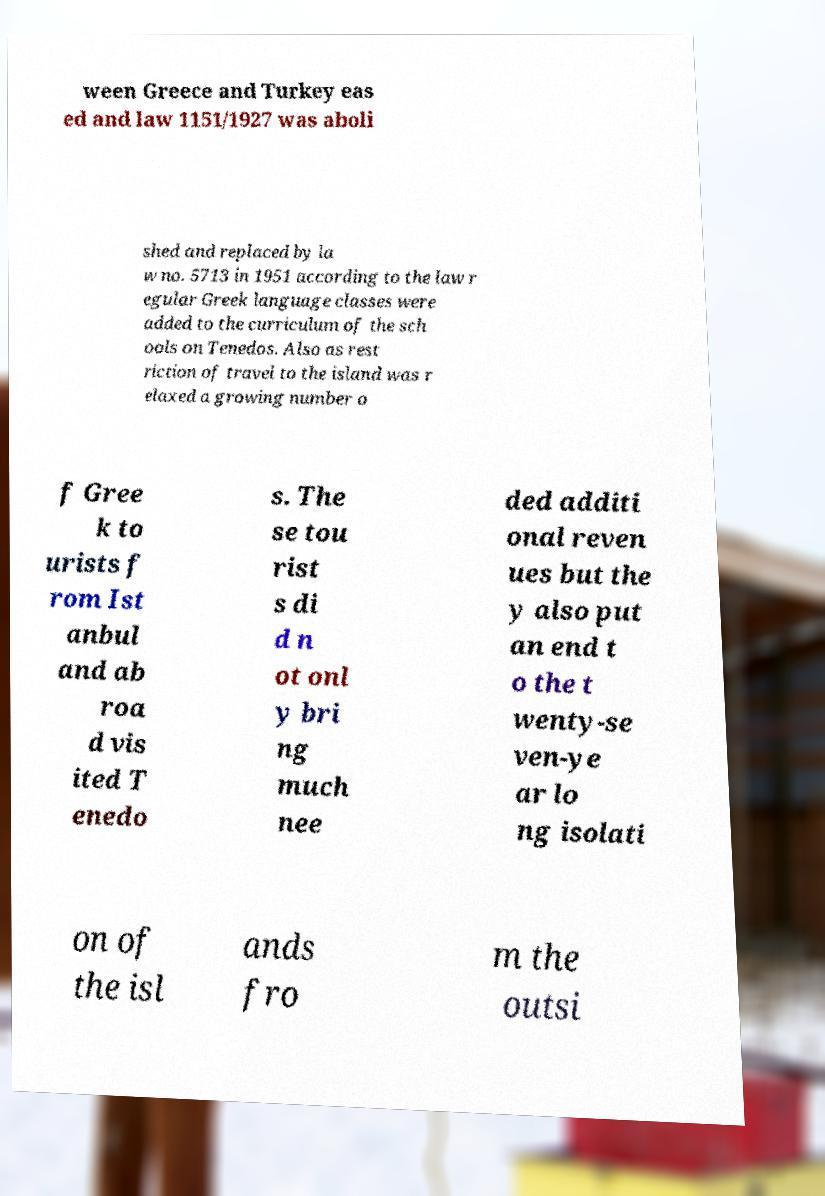Could you assist in decoding the text presented in this image and type it out clearly? ween Greece and Turkey eas ed and law 1151/1927 was aboli shed and replaced by la w no. 5713 in 1951 according to the law r egular Greek language classes were added to the curriculum of the sch ools on Tenedos. Also as rest riction of travel to the island was r elaxed a growing number o f Gree k to urists f rom Ist anbul and ab roa d vis ited T enedo s. The se tou rist s di d n ot onl y bri ng much nee ded additi onal reven ues but the y also put an end t o the t wenty-se ven-ye ar lo ng isolati on of the isl ands fro m the outsi 